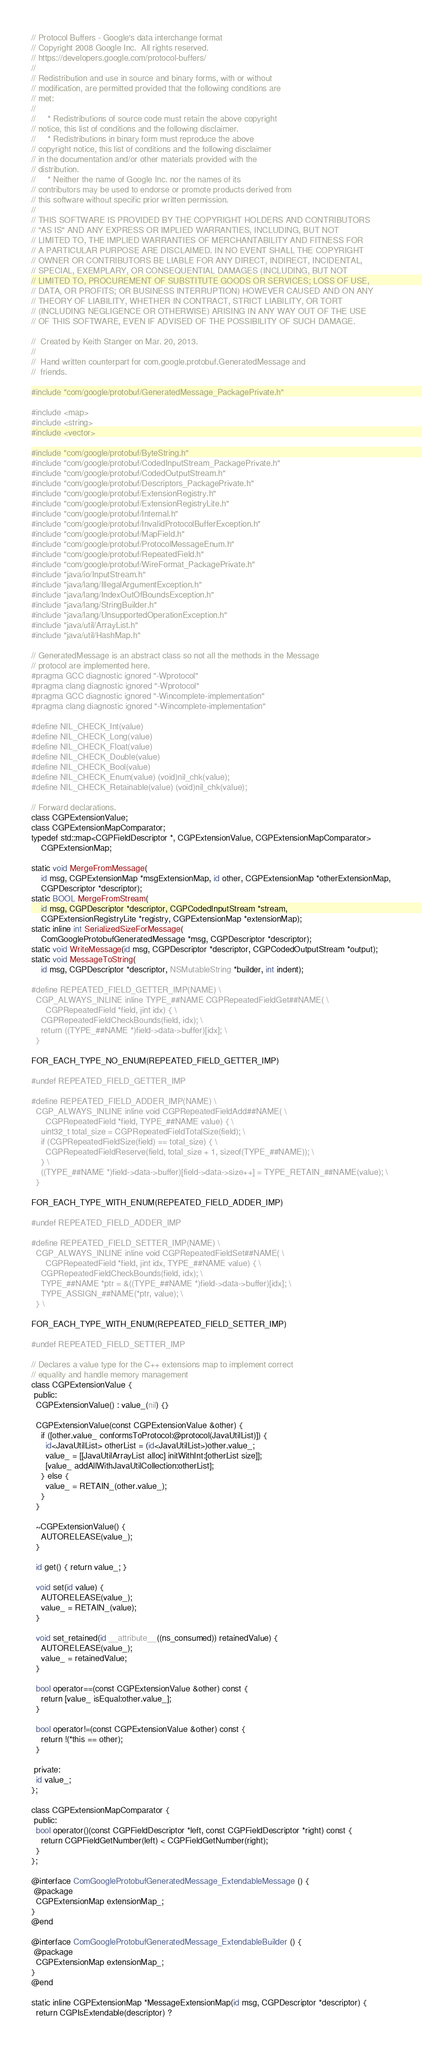Convert code to text. <code><loc_0><loc_0><loc_500><loc_500><_ObjectiveC_>// Protocol Buffers - Google's data interchange format
// Copyright 2008 Google Inc.  All rights reserved.
// https://developers.google.com/protocol-buffers/
//
// Redistribution and use in source and binary forms, with or without
// modification, are permitted provided that the following conditions are
// met:
//
//     * Redistributions of source code must retain the above copyright
// notice, this list of conditions and the following disclaimer.
//     * Redistributions in binary form must reproduce the above
// copyright notice, this list of conditions and the following disclaimer
// in the documentation and/or other materials provided with the
// distribution.
//     * Neither the name of Google Inc. nor the names of its
// contributors may be used to endorse or promote products derived from
// this software without specific prior written permission.
//
// THIS SOFTWARE IS PROVIDED BY THE COPYRIGHT HOLDERS AND CONTRIBUTORS
// "AS IS" AND ANY EXPRESS OR IMPLIED WARRANTIES, INCLUDING, BUT NOT
// LIMITED TO, THE IMPLIED WARRANTIES OF MERCHANTABILITY AND FITNESS FOR
// A PARTICULAR PURPOSE ARE DISCLAIMED. IN NO EVENT SHALL THE COPYRIGHT
// OWNER OR CONTRIBUTORS BE LIABLE FOR ANY DIRECT, INDIRECT, INCIDENTAL,
// SPECIAL, EXEMPLARY, OR CONSEQUENTIAL DAMAGES (INCLUDING, BUT NOT
// LIMITED TO, PROCUREMENT OF SUBSTITUTE GOODS OR SERVICES; LOSS OF USE,
// DATA, OR PROFITS; OR BUSINESS INTERRUPTION) HOWEVER CAUSED AND ON ANY
// THEORY OF LIABILITY, WHETHER IN CONTRACT, STRICT LIABILITY, OR TORT
// (INCLUDING NEGLIGENCE OR OTHERWISE) ARISING IN ANY WAY OUT OF THE USE
// OF THIS SOFTWARE, EVEN IF ADVISED OF THE POSSIBILITY OF SUCH DAMAGE.

//  Created by Keith Stanger on Mar. 20, 2013.
//
//  Hand written counterpart for com.google.protobuf.GeneratedMessage and
//  friends.

#include "com/google/protobuf/GeneratedMessage_PackagePrivate.h"

#include <map>
#include <string>
#include <vector>

#include "com/google/protobuf/ByteString.h"
#include "com/google/protobuf/CodedInputStream_PackagePrivate.h"
#include "com/google/protobuf/CodedOutputStream.h"
#include "com/google/protobuf/Descriptors_PackagePrivate.h"
#include "com/google/protobuf/ExtensionRegistry.h"
#include "com/google/protobuf/ExtensionRegistryLite.h"
#include "com/google/protobuf/Internal.h"
#include "com/google/protobuf/InvalidProtocolBufferException.h"
#include "com/google/protobuf/MapField.h"
#include "com/google/protobuf/ProtocolMessageEnum.h"
#include "com/google/protobuf/RepeatedField.h"
#include "com/google/protobuf/WireFormat_PackagePrivate.h"
#include "java/io/InputStream.h"
#include "java/lang/IllegalArgumentException.h"
#include "java/lang/IndexOutOfBoundsException.h"
#include "java/lang/StringBuilder.h"
#include "java/lang/UnsupportedOperationException.h"
#include "java/util/ArrayList.h"
#include "java/util/HashMap.h"

// GeneratedMessage is an abstract class so not all the methods in the Message
// protocol are implemented here.
#pragma GCC diagnostic ignored "-Wprotocol"
#pragma clang diagnostic ignored "-Wprotocol"
#pragma GCC diagnostic ignored "-Wincomplete-implementation"
#pragma clang diagnostic ignored "-Wincomplete-implementation"

#define NIL_CHECK_Int(value)
#define NIL_CHECK_Long(value)
#define NIL_CHECK_Float(value)
#define NIL_CHECK_Double(value)
#define NIL_CHECK_Bool(value)
#define NIL_CHECK_Enum(value) (void)nil_chk(value);
#define NIL_CHECK_Retainable(value) (void)nil_chk(value);

// Forward declarations.
class CGPExtensionValue;
class CGPExtensionMapComparator;
typedef std::map<CGPFieldDescriptor *, CGPExtensionValue, CGPExtensionMapComparator>
    CGPExtensionMap;

static void MergeFromMessage(
    id msg, CGPExtensionMap *msgExtensionMap, id other, CGPExtensionMap *otherExtensionMap,
    CGPDescriptor *descriptor);
static BOOL MergeFromStream(
    id msg, CGPDescriptor *descriptor, CGPCodedInputStream *stream,
    CGPExtensionRegistryLite *registry, CGPExtensionMap *extensionMap);
static inline int SerializedSizeForMessage(
    ComGoogleProtobufGeneratedMessage *msg, CGPDescriptor *descriptor);
static void WriteMessage(id msg, CGPDescriptor *descriptor, CGPCodedOutputStream *output);
static void MessageToString(
    id msg, CGPDescriptor *descriptor, NSMutableString *builder, int indent);

#define REPEATED_FIELD_GETTER_IMP(NAME) \
  CGP_ALWAYS_INLINE inline TYPE_##NAME CGPRepeatedFieldGet##NAME( \
      CGPRepeatedField *field, jint idx) { \
    CGPRepeatedFieldCheckBounds(field, idx); \
    return ((TYPE_##NAME *)field->data->buffer)[idx]; \
  }

FOR_EACH_TYPE_NO_ENUM(REPEATED_FIELD_GETTER_IMP)

#undef REPEATED_FIELD_GETTER_IMP

#define REPEATED_FIELD_ADDER_IMP(NAME) \
  CGP_ALWAYS_INLINE inline void CGPRepeatedFieldAdd##NAME( \
      CGPRepeatedField *field, TYPE_##NAME value) { \
    uint32_t total_size = CGPRepeatedFieldTotalSize(field); \
    if (CGPRepeatedFieldSize(field) == total_size) { \
      CGPRepeatedFieldReserve(field, total_size + 1, sizeof(TYPE_##NAME)); \
    } \
    ((TYPE_##NAME *)field->data->buffer)[field->data->size++] = TYPE_RETAIN_##NAME(value); \
  }

FOR_EACH_TYPE_WITH_ENUM(REPEATED_FIELD_ADDER_IMP)

#undef REPEATED_FIELD_ADDER_IMP

#define REPEATED_FIELD_SETTER_IMP(NAME) \
  CGP_ALWAYS_INLINE inline void CGPRepeatedFieldSet##NAME( \
      CGPRepeatedField *field, jint idx, TYPE_##NAME value) { \
    CGPRepeatedFieldCheckBounds(field, idx); \
    TYPE_##NAME *ptr = &((TYPE_##NAME *)field->data->buffer)[idx]; \
    TYPE_ASSIGN_##NAME(*ptr, value); \
  } \

FOR_EACH_TYPE_WITH_ENUM(REPEATED_FIELD_SETTER_IMP)

#undef REPEATED_FIELD_SETTER_IMP

// Declares a value type for the C++ extensions map to implement correct
// equality and handle memory management
class CGPExtensionValue {
 public:
  CGPExtensionValue() : value_(nil) {}

  CGPExtensionValue(const CGPExtensionValue &other) {
    if ([other.value_ conformsToProtocol:@protocol(JavaUtilList)]) {
      id<JavaUtilList> otherList = (id<JavaUtilList>)other.value_;
      value_ = [[JavaUtilArrayList alloc] initWithInt:[otherList size]];
      [value_ addAllWithJavaUtilCollection:otherList];
    } else {
      value_ = RETAIN_(other.value_);
    }
  }

  ~CGPExtensionValue() {
    AUTORELEASE(value_);
  }

  id get() { return value_; }

  void set(id value) {
    AUTORELEASE(value_);
    value_ = RETAIN_(value);
  }

  void set_retained(id __attribute__((ns_consumed)) retainedValue) {
    AUTORELEASE(value_);
    value_ = retainedValue;
  }

  bool operator==(const CGPExtensionValue &other) const {
    return [value_ isEqual:other.value_];
  }

  bool operator!=(const CGPExtensionValue &other) const {
    return !(*this == other);
  }

 private:
  id value_;
};

class CGPExtensionMapComparator {
 public:
  bool operator()(const CGPFieldDescriptor *left, const CGPFieldDescriptor *right) const {
    return CGPFieldGetNumber(left) < CGPFieldGetNumber(right);
  }
};

@interface ComGoogleProtobufGeneratedMessage_ExtendableMessage () {
 @package
  CGPExtensionMap extensionMap_;
}
@end

@interface ComGoogleProtobufGeneratedMessage_ExtendableBuilder () {
 @package
  CGPExtensionMap extensionMap_;
}
@end

static inline CGPExtensionMap *MessageExtensionMap(id msg, CGPDescriptor *descriptor) {
  return CGPIsExtendable(descriptor) ?</code> 